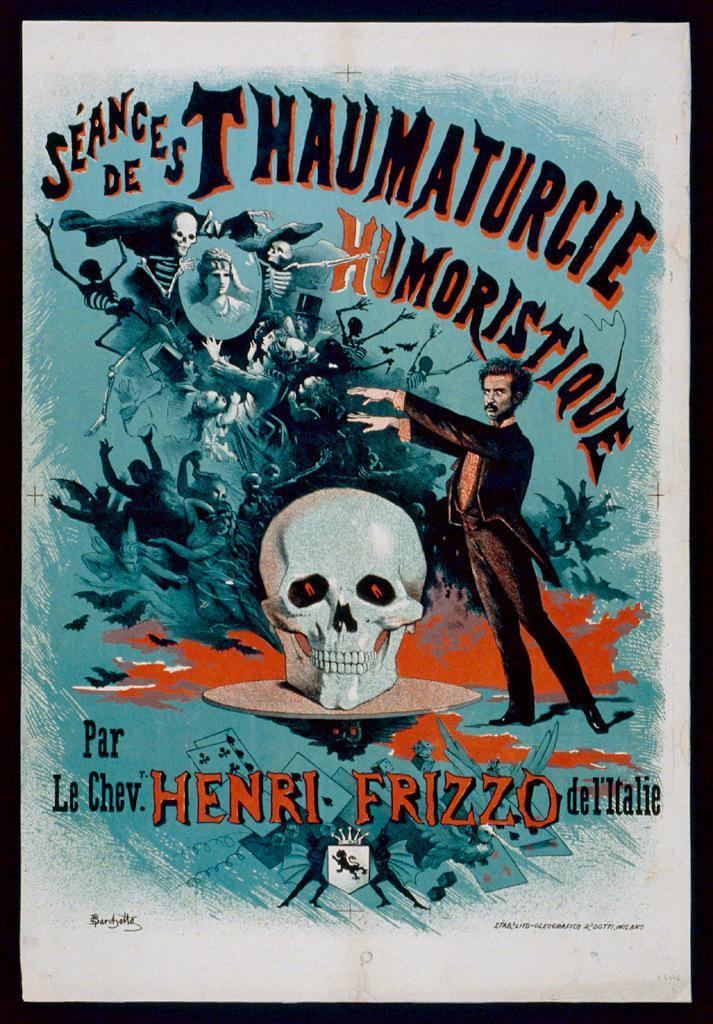Who is the author?
Provide a short and direct response. Henri frizzo. 